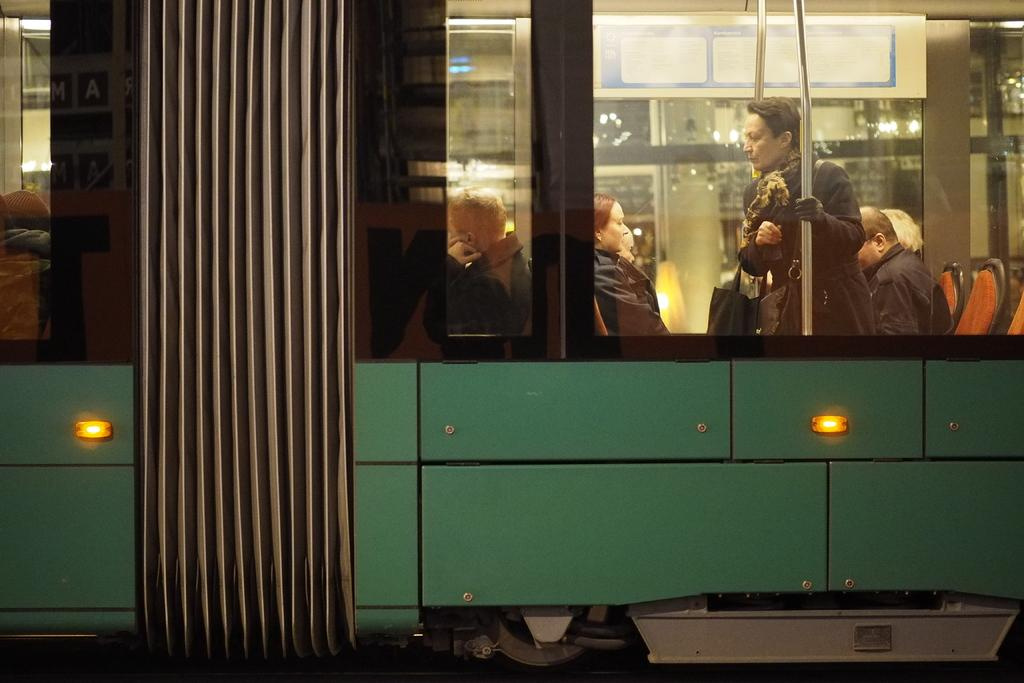What are the people in the image doing? The people in the image are sitting and standing in a train. Can you describe the standing person in the image? The standing person is holding a bag. Where is the bag visible in the image? The bag is visible on the right side of the image. Is the queen present in the image, sitting on her throne? No, there is no queen or throne present in the image. 